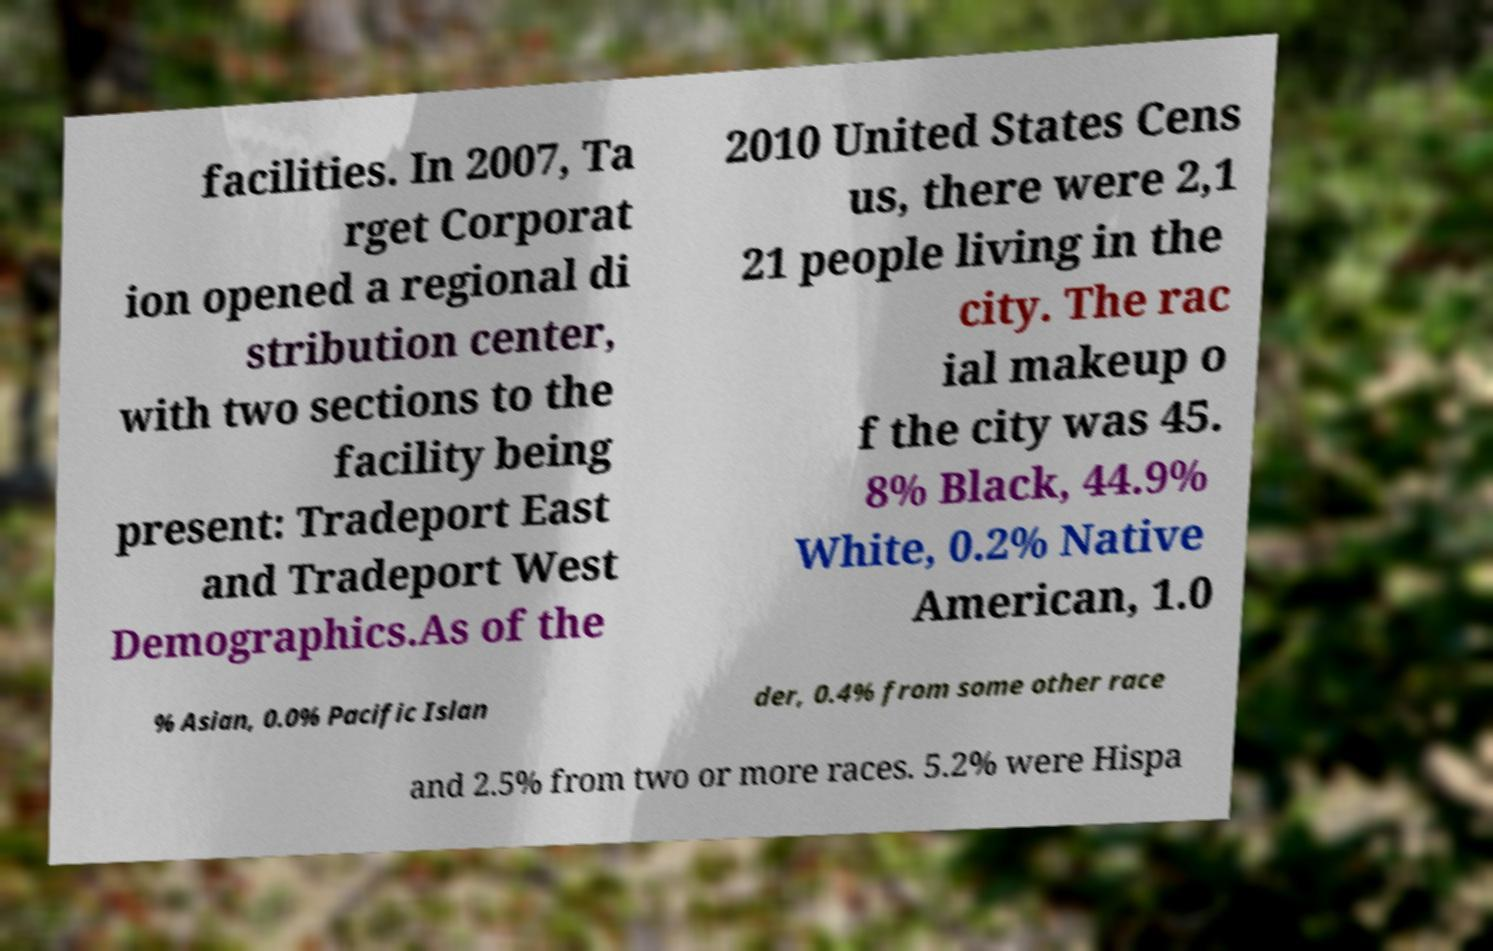Could you extract and type out the text from this image? facilities. In 2007, Ta rget Corporat ion opened a regional di stribution center, with two sections to the facility being present: Tradeport East and Tradeport West Demographics.As of the 2010 United States Cens us, there were 2,1 21 people living in the city. The rac ial makeup o f the city was 45. 8% Black, 44.9% White, 0.2% Native American, 1.0 % Asian, 0.0% Pacific Islan der, 0.4% from some other race and 2.5% from two or more races. 5.2% were Hispa 